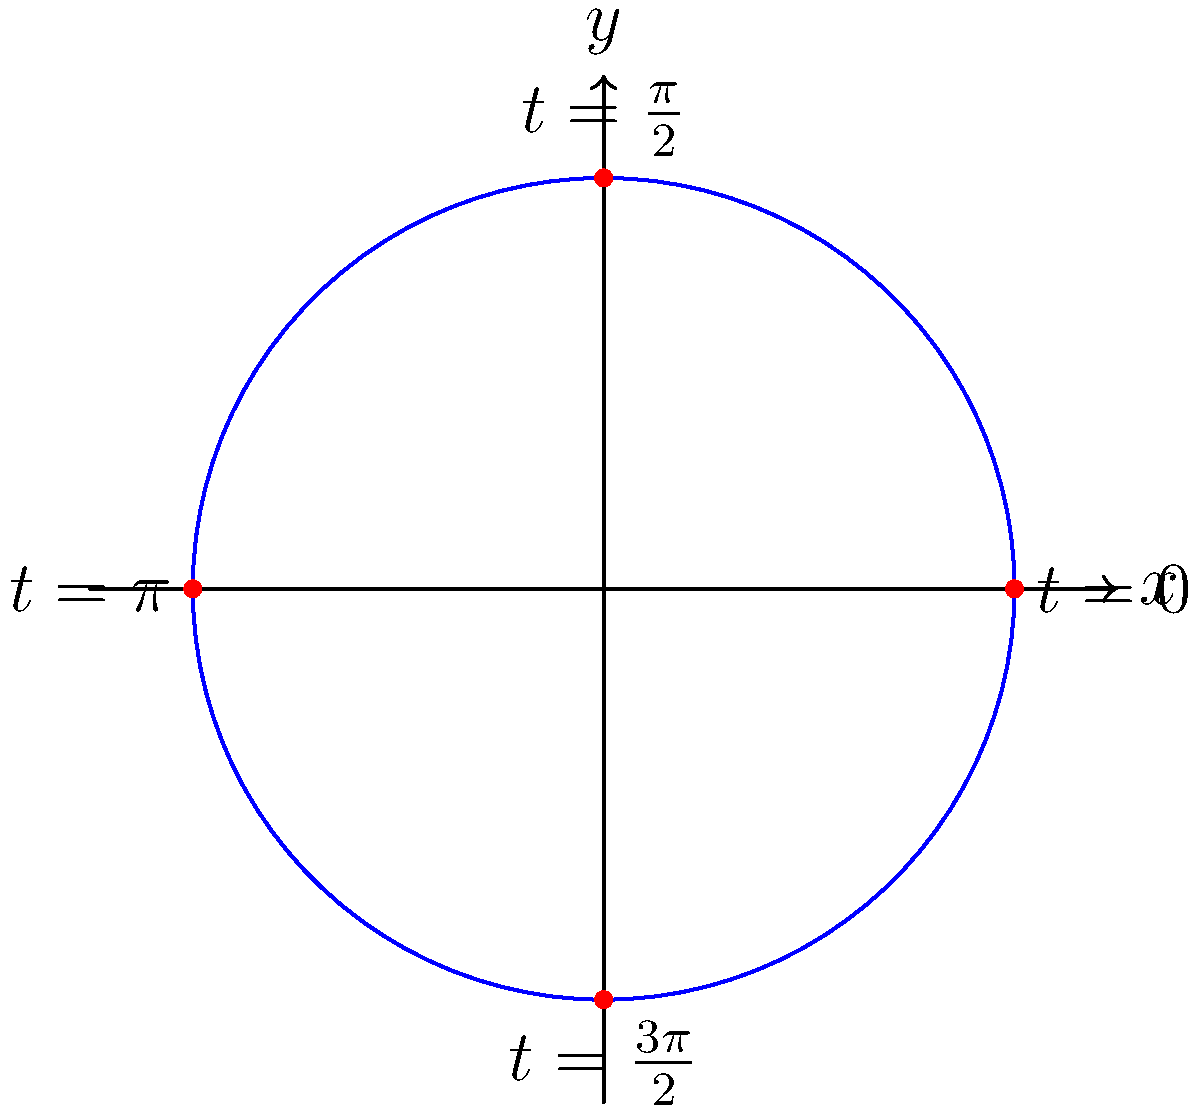In an effort to preserve and modernize traditional weaving patterns, you're working with an indigenous community to create a circular motif for textiles. The pattern can be modeled using parametric equations $x = 2\cos(t)$ and $y = 2\sin(t)$, where $t$ is the parameter. What is the total length of the circular path traced by these equations? To find the length of the circular path, we'll follow these steps:

1) The formula for the arc length of a curve given by parametric equations is:

   $$L = \int_{a}^{b} \sqrt{\left(\frac{dx}{dt}\right)^2 + \left(\frac{dy}{dt}\right)^2} dt$$

2) We need to find $\frac{dx}{dt}$ and $\frac{dy}{dt}$:
   
   $\frac{dx}{dt} = -2\sin(t)$
   $\frac{dy}{dt} = 2\cos(t)$

3) Substituting into the formula:

   $$L = \int_{0}^{2\pi} \sqrt{(-2\sin(t))^2 + (2\cos(t))^2} dt$$

4) Simplify inside the square root:

   $$L = \int_{0}^{2\pi} \sqrt{4\sin^2(t) + 4\cos^2(t)} dt$$

5) Recall the trigonometric identity $\sin^2(t) + \cos^2(t) = 1$:

   $$L = \int_{0}^{2\pi} \sqrt{4(\sin^2(t) + \cos^2(t))} dt = \int_{0}^{2\pi} \sqrt{4} dt = \int_{0}^{2\pi} 2 dt$$

6) Evaluate the integral:

   $$L = 2t \bigg|_{0}^{2\pi} = 2(2\pi - 0) = 4\pi$$

Therefore, the total length of the circular path is $4\pi$ units.
Answer: $4\pi$ units 